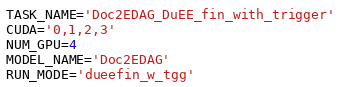Convert code to text. <code><loc_0><loc_0><loc_500><loc_500><_Bash_>TASK_NAME='Doc2EDAG_DuEE_fin_with_trigger'
CUDA='0,1,2,3'
NUM_GPU=4
MODEL_NAME='Doc2EDAG'
RUN_MODE='dueefin_w_tgg'</code> 